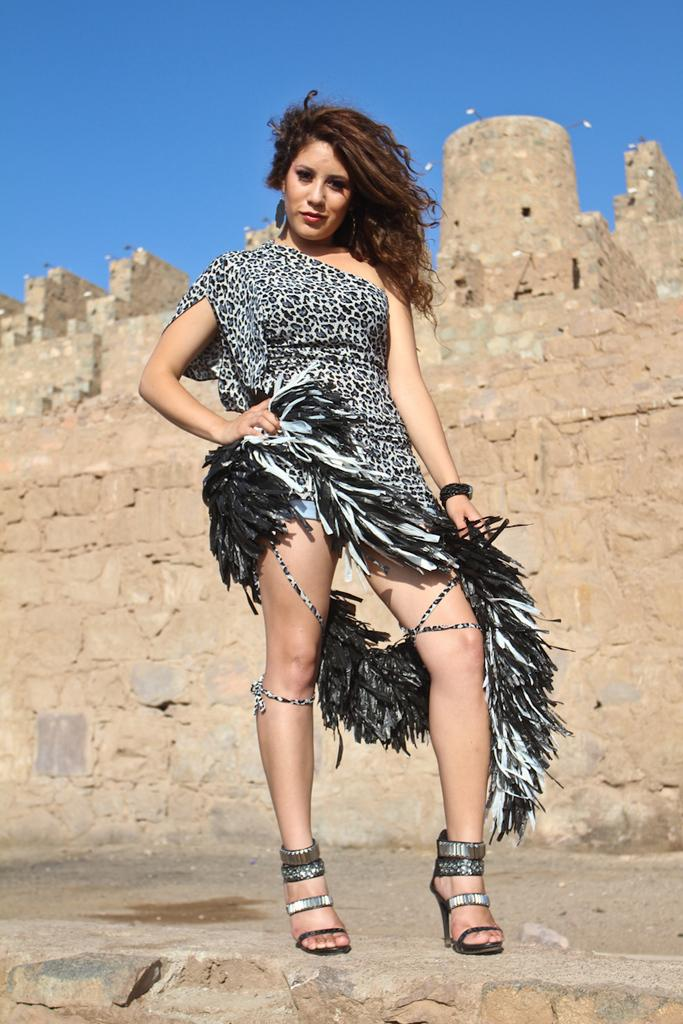What is the main subject in the image? There is a lady standing in the image. What can be seen in the background of the image? There is a fort in the background of the image. Where is the seat located in the image? There is no seat present in the image. What type of tank can be seen near the fort in the image? There is no tank present in the image; only the lady and the fort are visible. 